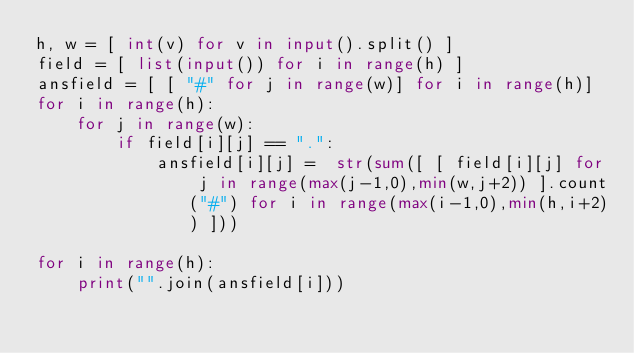Convert code to text. <code><loc_0><loc_0><loc_500><loc_500><_Python_>h, w = [ int(v) for v in input().split() ]
field = [ list(input()) for i in range(h) ]
ansfield = [ [ "#" for j in range(w)] for i in range(h)]
for i in range(h):
	for j in range(w):
		if field[i][j] == ".":
			ansfield[i][j] =  str(sum([ [ field[i][j] for j in range(max(j-1,0),min(w,j+2)) ].count("#") for i in range(max(i-1,0),min(h,i+2)) ]))

for i in range(h):
	print("".join(ansfield[i]))</code> 